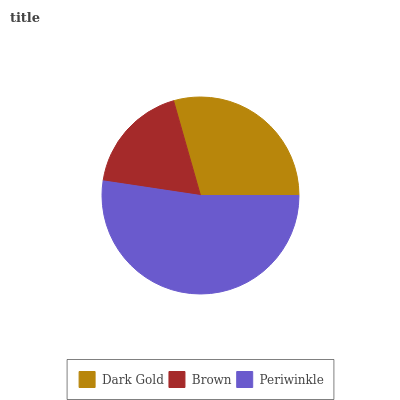Is Brown the minimum?
Answer yes or no. Yes. Is Periwinkle the maximum?
Answer yes or no. Yes. Is Periwinkle the minimum?
Answer yes or no. No. Is Brown the maximum?
Answer yes or no. No. Is Periwinkle greater than Brown?
Answer yes or no. Yes. Is Brown less than Periwinkle?
Answer yes or no. Yes. Is Brown greater than Periwinkle?
Answer yes or no. No. Is Periwinkle less than Brown?
Answer yes or no. No. Is Dark Gold the high median?
Answer yes or no. Yes. Is Dark Gold the low median?
Answer yes or no. Yes. Is Brown the high median?
Answer yes or no. No. Is Periwinkle the low median?
Answer yes or no. No. 